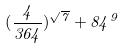Convert formula to latex. <formula><loc_0><loc_0><loc_500><loc_500>( \frac { 4 } { 3 6 4 } ) ^ { \sqrt { 7 } } + 8 4 ^ { 9 }</formula> 